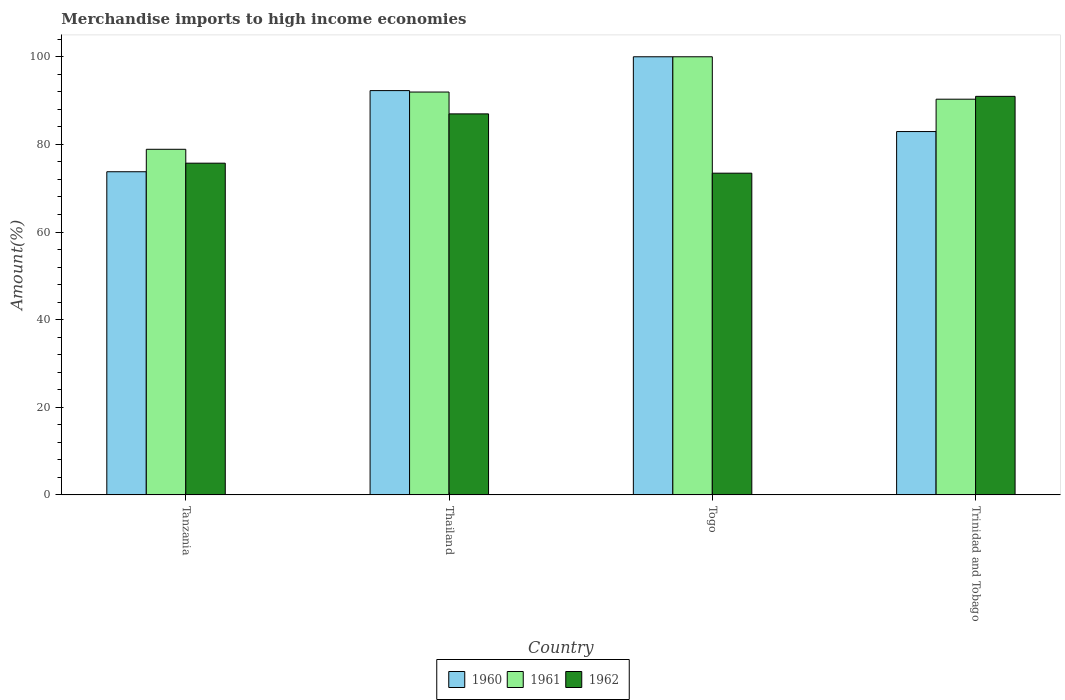How many bars are there on the 3rd tick from the left?
Provide a short and direct response. 3. What is the label of the 1st group of bars from the left?
Keep it short and to the point. Tanzania. In how many cases, is the number of bars for a given country not equal to the number of legend labels?
Your answer should be compact. 0. What is the percentage of amount earned from merchandise imports in 1962 in Trinidad and Tobago?
Offer a terse response. 90.97. Across all countries, what is the minimum percentage of amount earned from merchandise imports in 1960?
Ensure brevity in your answer.  73.76. In which country was the percentage of amount earned from merchandise imports in 1960 maximum?
Your response must be concise. Togo. In which country was the percentage of amount earned from merchandise imports in 1962 minimum?
Your answer should be compact. Togo. What is the total percentage of amount earned from merchandise imports in 1961 in the graph?
Your answer should be compact. 361.16. What is the difference between the percentage of amount earned from merchandise imports in 1960 in Togo and that in Trinidad and Tobago?
Make the answer very short. 17.07. What is the difference between the percentage of amount earned from merchandise imports in 1961 in Thailand and the percentage of amount earned from merchandise imports in 1960 in Trinidad and Tobago?
Keep it short and to the point. 9.02. What is the average percentage of amount earned from merchandise imports in 1961 per country?
Your answer should be very brief. 90.29. What is the difference between the percentage of amount earned from merchandise imports of/in 1962 and percentage of amount earned from merchandise imports of/in 1960 in Trinidad and Tobago?
Your response must be concise. 8.03. What is the ratio of the percentage of amount earned from merchandise imports in 1960 in Thailand to that in Trinidad and Tobago?
Your answer should be very brief. 1.11. Is the percentage of amount earned from merchandise imports in 1962 in Tanzania less than that in Togo?
Keep it short and to the point. No. Is the difference between the percentage of amount earned from merchandise imports in 1962 in Tanzania and Thailand greater than the difference between the percentage of amount earned from merchandise imports in 1960 in Tanzania and Thailand?
Ensure brevity in your answer.  Yes. What is the difference between the highest and the second highest percentage of amount earned from merchandise imports in 1960?
Ensure brevity in your answer.  -17.07. What is the difference between the highest and the lowest percentage of amount earned from merchandise imports in 1961?
Make the answer very short. 21.11. What does the 3rd bar from the right in Trinidad and Tobago represents?
Provide a succinct answer. 1960. Is it the case that in every country, the sum of the percentage of amount earned from merchandise imports in 1960 and percentage of amount earned from merchandise imports in 1961 is greater than the percentage of amount earned from merchandise imports in 1962?
Ensure brevity in your answer.  Yes. How many countries are there in the graph?
Make the answer very short. 4. Are the values on the major ticks of Y-axis written in scientific E-notation?
Offer a terse response. No. Does the graph contain any zero values?
Provide a short and direct response. No. Does the graph contain grids?
Your response must be concise. No. Where does the legend appear in the graph?
Keep it short and to the point. Bottom center. How are the legend labels stacked?
Make the answer very short. Horizontal. What is the title of the graph?
Make the answer very short. Merchandise imports to high income economies. What is the label or title of the Y-axis?
Make the answer very short. Amount(%). What is the Amount(%) in 1960 in Tanzania?
Provide a succinct answer. 73.76. What is the Amount(%) in 1961 in Tanzania?
Offer a terse response. 78.89. What is the Amount(%) in 1962 in Tanzania?
Your response must be concise. 75.71. What is the Amount(%) of 1960 in Thailand?
Keep it short and to the point. 92.28. What is the Amount(%) in 1961 in Thailand?
Give a very brief answer. 91.95. What is the Amount(%) in 1962 in Thailand?
Offer a very short reply. 86.97. What is the Amount(%) of 1960 in Togo?
Ensure brevity in your answer.  100. What is the Amount(%) of 1962 in Togo?
Provide a short and direct response. 73.43. What is the Amount(%) in 1960 in Trinidad and Tobago?
Your answer should be compact. 82.93. What is the Amount(%) of 1961 in Trinidad and Tobago?
Your answer should be compact. 90.32. What is the Amount(%) of 1962 in Trinidad and Tobago?
Provide a short and direct response. 90.97. Across all countries, what is the maximum Amount(%) in 1960?
Your answer should be very brief. 100. Across all countries, what is the maximum Amount(%) of 1961?
Provide a succinct answer. 100. Across all countries, what is the maximum Amount(%) of 1962?
Offer a very short reply. 90.97. Across all countries, what is the minimum Amount(%) of 1960?
Keep it short and to the point. 73.76. Across all countries, what is the minimum Amount(%) of 1961?
Provide a succinct answer. 78.89. Across all countries, what is the minimum Amount(%) of 1962?
Your response must be concise. 73.43. What is the total Amount(%) in 1960 in the graph?
Offer a very short reply. 348.98. What is the total Amount(%) in 1961 in the graph?
Give a very brief answer. 361.16. What is the total Amount(%) of 1962 in the graph?
Offer a very short reply. 327.08. What is the difference between the Amount(%) of 1960 in Tanzania and that in Thailand?
Your answer should be compact. -18.52. What is the difference between the Amount(%) in 1961 in Tanzania and that in Thailand?
Keep it short and to the point. -13.06. What is the difference between the Amount(%) in 1962 in Tanzania and that in Thailand?
Provide a succinct answer. -11.25. What is the difference between the Amount(%) in 1960 in Tanzania and that in Togo?
Make the answer very short. -26.24. What is the difference between the Amount(%) of 1961 in Tanzania and that in Togo?
Provide a succinct answer. -21.11. What is the difference between the Amount(%) in 1962 in Tanzania and that in Togo?
Your answer should be compact. 2.28. What is the difference between the Amount(%) of 1960 in Tanzania and that in Trinidad and Tobago?
Ensure brevity in your answer.  -9.17. What is the difference between the Amount(%) in 1961 in Tanzania and that in Trinidad and Tobago?
Provide a succinct answer. -11.43. What is the difference between the Amount(%) of 1962 in Tanzania and that in Trinidad and Tobago?
Provide a succinct answer. -15.25. What is the difference between the Amount(%) of 1960 in Thailand and that in Togo?
Offer a terse response. -7.72. What is the difference between the Amount(%) of 1961 in Thailand and that in Togo?
Your answer should be compact. -8.05. What is the difference between the Amount(%) in 1962 in Thailand and that in Togo?
Make the answer very short. 13.53. What is the difference between the Amount(%) of 1960 in Thailand and that in Trinidad and Tobago?
Offer a very short reply. 9.35. What is the difference between the Amount(%) of 1961 in Thailand and that in Trinidad and Tobago?
Offer a terse response. 1.63. What is the difference between the Amount(%) of 1962 in Thailand and that in Trinidad and Tobago?
Your response must be concise. -4. What is the difference between the Amount(%) in 1960 in Togo and that in Trinidad and Tobago?
Offer a terse response. 17.07. What is the difference between the Amount(%) in 1961 in Togo and that in Trinidad and Tobago?
Offer a terse response. 9.68. What is the difference between the Amount(%) of 1962 in Togo and that in Trinidad and Tobago?
Provide a succinct answer. -17.54. What is the difference between the Amount(%) in 1960 in Tanzania and the Amount(%) in 1961 in Thailand?
Keep it short and to the point. -18.19. What is the difference between the Amount(%) of 1960 in Tanzania and the Amount(%) of 1962 in Thailand?
Give a very brief answer. -13.2. What is the difference between the Amount(%) of 1961 in Tanzania and the Amount(%) of 1962 in Thailand?
Provide a succinct answer. -8.08. What is the difference between the Amount(%) of 1960 in Tanzania and the Amount(%) of 1961 in Togo?
Your response must be concise. -26.24. What is the difference between the Amount(%) in 1960 in Tanzania and the Amount(%) in 1962 in Togo?
Give a very brief answer. 0.33. What is the difference between the Amount(%) in 1961 in Tanzania and the Amount(%) in 1962 in Togo?
Ensure brevity in your answer.  5.45. What is the difference between the Amount(%) in 1960 in Tanzania and the Amount(%) in 1961 in Trinidad and Tobago?
Offer a very short reply. -16.56. What is the difference between the Amount(%) of 1960 in Tanzania and the Amount(%) of 1962 in Trinidad and Tobago?
Provide a succinct answer. -17.21. What is the difference between the Amount(%) of 1961 in Tanzania and the Amount(%) of 1962 in Trinidad and Tobago?
Offer a very short reply. -12.08. What is the difference between the Amount(%) in 1960 in Thailand and the Amount(%) in 1961 in Togo?
Provide a succinct answer. -7.72. What is the difference between the Amount(%) in 1960 in Thailand and the Amount(%) in 1962 in Togo?
Keep it short and to the point. 18.85. What is the difference between the Amount(%) of 1961 in Thailand and the Amount(%) of 1962 in Togo?
Your answer should be compact. 18.52. What is the difference between the Amount(%) of 1960 in Thailand and the Amount(%) of 1961 in Trinidad and Tobago?
Your answer should be very brief. 1.96. What is the difference between the Amount(%) in 1960 in Thailand and the Amount(%) in 1962 in Trinidad and Tobago?
Make the answer very short. 1.31. What is the difference between the Amount(%) of 1960 in Togo and the Amount(%) of 1961 in Trinidad and Tobago?
Your answer should be very brief. 9.68. What is the difference between the Amount(%) in 1960 in Togo and the Amount(%) in 1962 in Trinidad and Tobago?
Your answer should be very brief. 9.03. What is the difference between the Amount(%) of 1961 in Togo and the Amount(%) of 1962 in Trinidad and Tobago?
Provide a short and direct response. 9.03. What is the average Amount(%) in 1960 per country?
Offer a terse response. 87.24. What is the average Amount(%) of 1961 per country?
Ensure brevity in your answer.  90.29. What is the average Amount(%) in 1962 per country?
Provide a succinct answer. 81.77. What is the difference between the Amount(%) of 1960 and Amount(%) of 1961 in Tanzania?
Your answer should be very brief. -5.13. What is the difference between the Amount(%) of 1960 and Amount(%) of 1962 in Tanzania?
Your answer should be very brief. -1.95. What is the difference between the Amount(%) in 1961 and Amount(%) in 1962 in Tanzania?
Offer a very short reply. 3.17. What is the difference between the Amount(%) in 1960 and Amount(%) in 1961 in Thailand?
Provide a succinct answer. 0.33. What is the difference between the Amount(%) in 1960 and Amount(%) in 1962 in Thailand?
Ensure brevity in your answer.  5.32. What is the difference between the Amount(%) in 1961 and Amount(%) in 1962 in Thailand?
Offer a very short reply. 4.99. What is the difference between the Amount(%) of 1960 and Amount(%) of 1961 in Togo?
Offer a very short reply. 0. What is the difference between the Amount(%) of 1960 and Amount(%) of 1962 in Togo?
Your answer should be compact. 26.57. What is the difference between the Amount(%) of 1961 and Amount(%) of 1962 in Togo?
Your response must be concise. 26.57. What is the difference between the Amount(%) in 1960 and Amount(%) in 1961 in Trinidad and Tobago?
Make the answer very short. -7.38. What is the difference between the Amount(%) in 1960 and Amount(%) in 1962 in Trinidad and Tobago?
Provide a succinct answer. -8.03. What is the difference between the Amount(%) of 1961 and Amount(%) of 1962 in Trinidad and Tobago?
Offer a terse response. -0.65. What is the ratio of the Amount(%) in 1960 in Tanzania to that in Thailand?
Your answer should be very brief. 0.8. What is the ratio of the Amount(%) in 1961 in Tanzania to that in Thailand?
Give a very brief answer. 0.86. What is the ratio of the Amount(%) of 1962 in Tanzania to that in Thailand?
Your answer should be very brief. 0.87. What is the ratio of the Amount(%) in 1960 in Tanzania to that in Togo?
Provide a short and direct response. 0.74. What is the ratio of the Amount(%) in 1961 in Tanzania to that in Togo?
Offer a terse response. 0.79. What is the ratio of the Amount(%) of 1962 in Tanzania to that in Togo?
Provide a short and direct response. 1.03. What is the ratio of the Amount(%) of 1960 in Tanzania to that in Trinidad and Tobago?
Your answer should be compact. 0.89. What is the ratio of the Amount(%) in 1961 in Tanzania to that in Trinidad and Tobago?
Ensure brevity in your answer.  0.87. What is the ratio of the Amount(%) in 1962 in Tanzania to that in Trinidad and Tobago?
Offer a terse response. 0.83. What is the ratio of the Amount(%) of 1960 in Thailand to that in Togo?
Your response must be concise. 0.92. What is the ratio of the Amount(%) in 1961 in Thailand to that in Togo?
Your answer should be very brief. 0.92. What is the ratio of the Amount(%) in 1962 in Thailand to that in Togo?
Provide a succinct answer. 1.18. What is the ratio of the Amount(%) of 1960 in Thailand to that in Trinidad and Tobago?
Provide a succinct answer. 1.11. What is the ratio of the Amount(%) of 1961 in Thailand to that in Trinidad and Tobago?
Provide a succinct answer. 1.02. What is the ratio of the Amount(%) of 1962 in Thailand to that in Trinidad and Tobago?
Make the answer very short. 0.96. What is the ratio of the Amount(%) of 1960 in Togo to that in Trinidad and Tobago?
Make the answer very short. 1.21. What is the ratio of the Amount(%) of 1961 in Togo to that in Trinidad and Tobago?
Your answer should be compact. 1.11. What is the ratio of the Amount(%) in 1962 in Togo to that in Trinidad and Tobago?
Provide a succinct answer. 0.81. What is the difference between the highest and the second highest Amount(%) in 1960?
Provide a succinct answer. 7.72. What is the difference between the highest and the second highest Amount(%) in 1961?
Ensure brevity in your answer.  8.05. What is the difference between the highest and the second highest Amount(%) in 1962?
Provide a short and direct response. 4. What is the difference between the highest and the lowest Amount(%) of 1960?
Offer a very short reply. 26.24. What is the difference between the highest and the lowest Amount(%) of 1961?
Your answer should be compact. 21.11. What is the difference between the highest and the lowest Amount(%) in 1962?
Offer a very short reply. 17.54. 